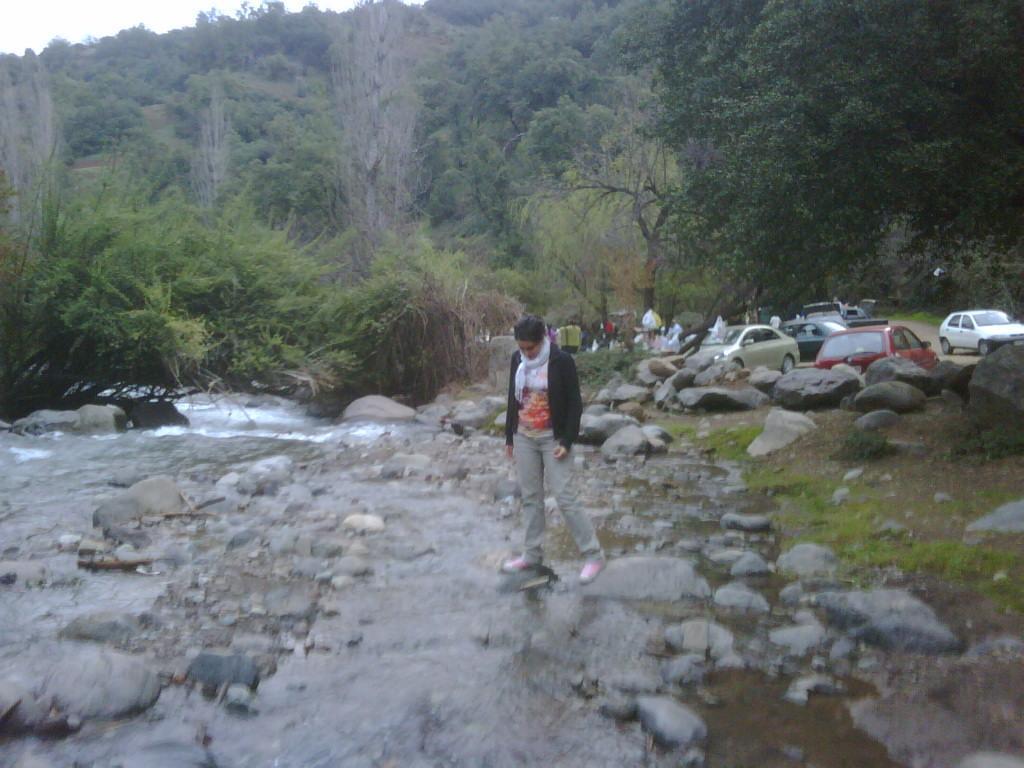How would you summarize this image in a sentence or two? In this picture there is water and rocks at the bottom side of the image and there are cars and other people on the right side of the image, there are trees at the top side of the image. 